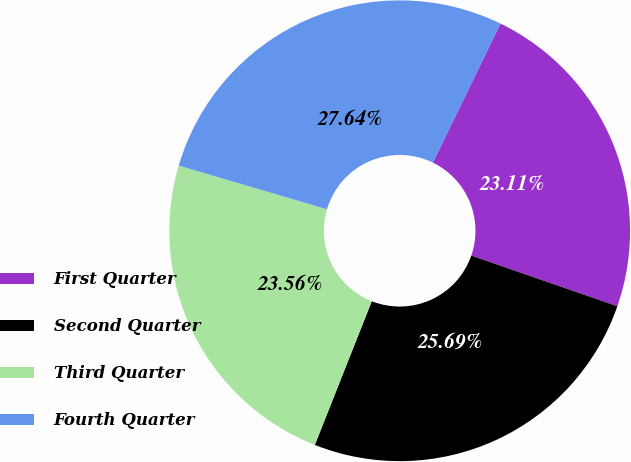<chart> <loc_0><loc_0><loc_500><loc_500><pie_chart><fcel>First Quarter<fcel>Second Quarter<fcel>Third Quarter<fcel>Fourth Quarter<nl><fcel>23.11%<fcel>25.69%<fcel>23.56%<fcel>27.64%<nl></chart> 